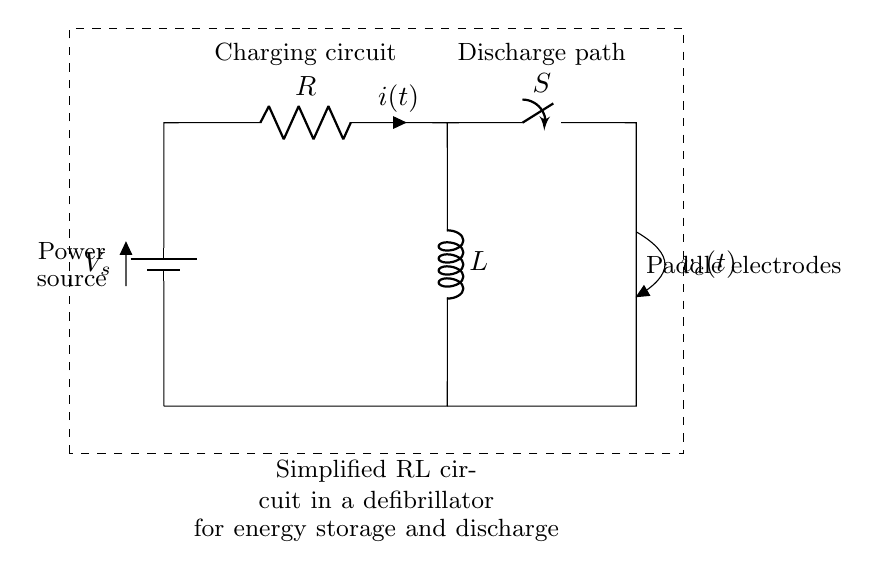What is the source voltage in the circuit? The source voltage, denoted as V_s in the diagram, represents the voltage provided by the battery. It is positioned at the top left of the circuit.
Answer: V_s What components are present in the circuit? The circuit diagram includes a power source (battery), a resistor (R), an inductor (L), and a switch (S). These components are clearly labeled in the circuit.
Answer: Battery, Resistor, Inductor, Switch What is the purpose of the switch in this circuit? The switch (S) allows control over the path of electric current. By opening or closing the switch, the current can either charge the circuit or discharge energy through the paddle electrodes.
Answer: Control of current path How does current behave when the switch is closed? When the switch is closed, current flows through the circuit from the battery, charging the inductor and resistor. The inductor stores energy in its magnetic field, while the resistor dissipates energy as heat.
Answer: Current flows and charges components What happens when the switch is opened after charging? Opening the switch interrupts the current flow; the inductor will then discharge its stored energy through the load (paddle electrodes) connected to it, delivering a shock.
Answer: Inductor discharges energy What role does the inductor play in this circuit? The inductor (L) stores energy when current passes through it by creating a magnetic field. Upon discharge, it releases this energy, which is essential for delivering potential lifesaving shocks in a defibrillator.
Answer: Energy storage and release 